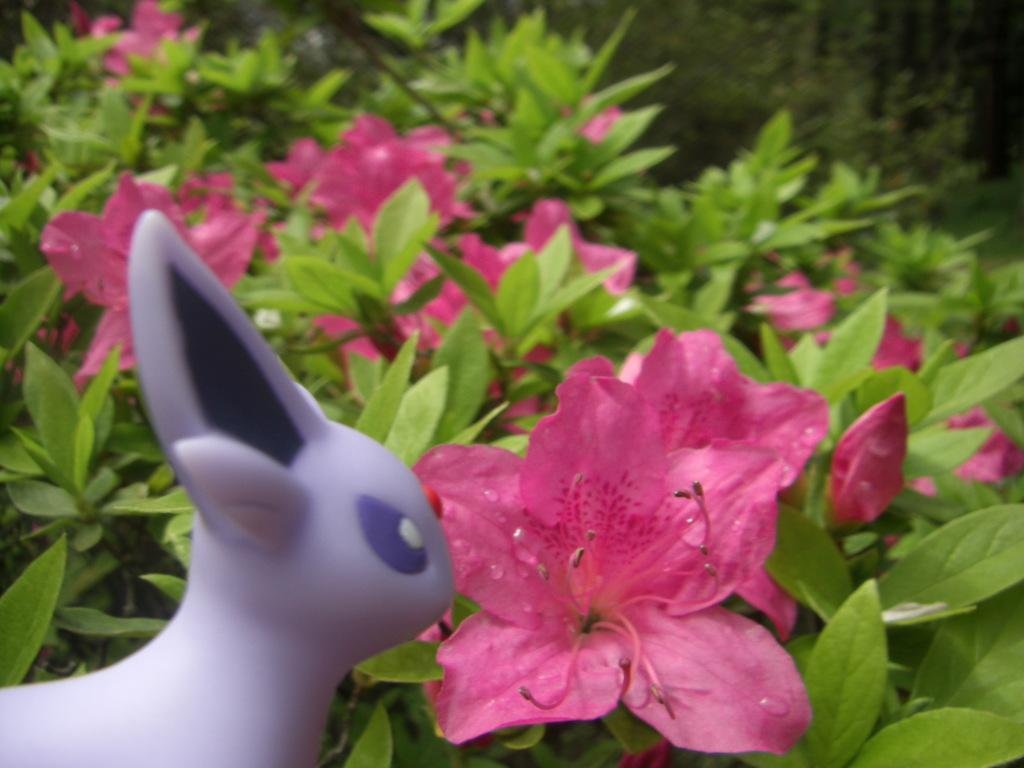What type of living organisms can be seen in the image? Plants and flowers are visible in the image. Can you describe the toy on the right side of the image? Unfortunately, the facts provided do not give any details about the toy, so we cannot describe it. What is the primary difference between the plants and flowers in the image? The plants and flowers in the image are different in that plants are typically larger and provide support for the flowers. Can you tell me the grade of the lake in the image? There is no lake present in the image, so we cannot determine its grade. What type of wheel is visible in the image? There is no wheel present in the image. 